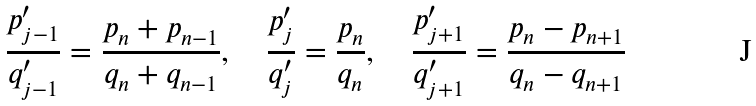Convert formula to latex. <formula><loc_0><loc_0><loc_500><loc_500>\frac { p _ { j - 1 } ^ { \prime } } { q _ { j - 1 } ^ { \prime } } = \frac { p _ { n } + p _ { n - 1 } } { q _ { n } + q _ { n - 1 } } , \quad \frac { p _ { j } ^ { \prime } } { q _ { j } ^ { \prime } } = \frac { p _ { n } } { q _ { n } } , \quad \frac { p _ { j + 1 } ^ { \prime } } { q _ { j + 1 } ^ { \prime } } = \frac { p _ { n } - p _ { n + 1 } } { q _ { n } - q _ { n + 1 } }</formula> 